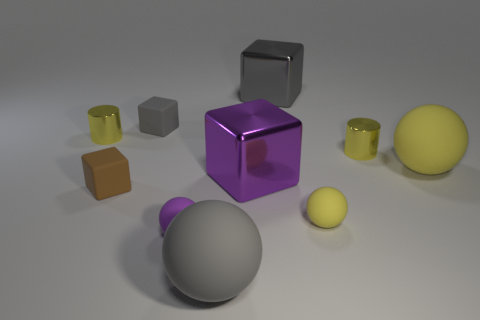Subtract all small gray rubber blocks. How many blocks are left? 3 Subtract all yellow spheres. How many spheres are left? 2 Subtract all cylinders. How many objects are left? 8 Subtract 4 spheres. How many spheres are left? 0 Subtract all brown cylinders. Subtract all green spheres. How many cylinders are left? 2 Subtract all red spheres. How many purple cylinders are left? 0 Subtract all big purple metal objects. Subtract all small yellow metal things. How many objects are left? 7 Add 3 small gray rubber objects. How many small gray rubber objects are left? 4 Add 4 yellow spheres. How many yellow spheres exist? 6 Subtract 1 yellow spheres. How many objects are left? 9 